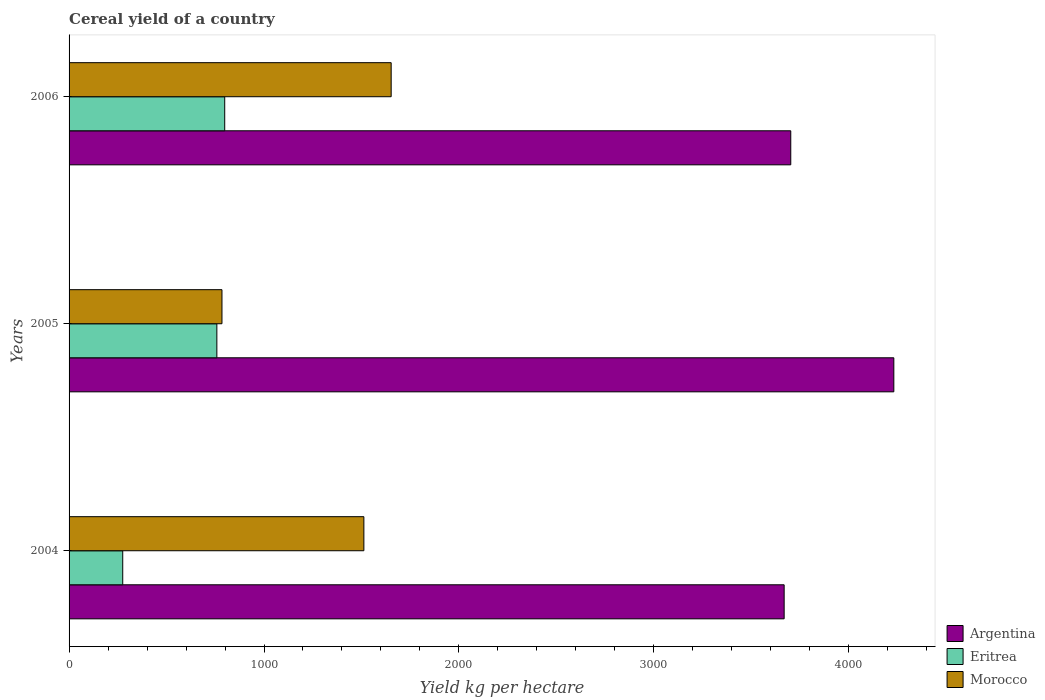How many different coloured bars are there?
Keep it short and to the point. 3. How many groups of bars are there?
Make the answer very short. 3. What is the label of the 3rd group of bars from the top?
Your answer should be very brief. 2004. In how many cases, is the number of bars for a given year not equal to the number of legend labels?
Your answer should be compact. 0. What is the total cereal yield in Eritrea in 2004?
Offer a very short reply. 275.29. Across all years, what is the maximum total cereal yield in Argentina?
Give a very brief answer. 4231.04. Across all years, what is the minimum total cereal yield in Eritrea?
Make the answer very short. 275.29. In which year was the total cereal yield in Morocco minimum?
Provide a short and direct response. 2005. What is the total total cereal yield in Argentina in the graph?
Offer a terse response. 1.16e+04. What is the difference between the total cereal yield in Eritrea in 2004 and that in 2006?
Provide a short and direct response. -523.19. What is the difference between the total cereal yield in Eritrea in 2004 and the total cereal yield in Morocco in 2005?
Offer a terse response. -509.06. What is the average total cereal yield in Morocco per year?
Provide a short and direct response. 1316.36. In the year 2006, what is the difference between the total cereal yield in Eritrea and total cereal yield in Morocco?
Provide a short and direct response. -853.93. In how many years, is the total cereal yield in Argentina greater than 4000 kg per hectare?
Your answer should be compact. 1. What is the ratio of the total cereal yield in Morocco in 2004 to that in 2006?
Provide a short and direct response. 0.92. Is the total cereal yield in Argentina in 2005 less than that in 2006?
Your response must be concise. No. Is the difference between the total cereal yield in Eritrea in 2004 and 2005 greater than the difference between the total cereal yield in Morocco in 2004 and 2005?
Provide a short and direct response. No. What is the difference between the highest and the second highest total cereal yield in Eritrea?
Your answer should be compact. 40.28. What is the difference between the highest and the lowest total cereal yield in Eritrea?
Make the answer very short. 523.19. In how many years, is the total cereal yield in Morocco greater than the average total cereal yield in Morocco taken over all years?
Offer a very short reply. 2. Is the sum of the total cereal yield in Eritrea in 2004 and 2006 greater than the maximum total cereal yield in Argentina across all years?
Your answer should be compact. No. What does the 1st bar from the top in 2004 represents?
Ensure brevity in your answer.  Morocco. What does the 3rd bar from the bottom in 2005 represents?
Your response must be concise. Morocco. Is it the case that in every year, the sum of the total cereal yield in Morocco and total cereal yield in Argentina is greater than the total cereal yield in Eritrea?
Provide a short and direct response. Yes. How many bars are there?
Offer a very short reply. 9. Are all the bars in the graph horizontal?
Provide a short and direct response. Yes. How many years are there in the graph?
Your response must be concise. 3. Where does the legend appear in the graph?
Your answer should be compact. Bottom right. How are the legend labels stacked?
Give a very brief answer. Vertical. What is the title of the graph?
Ensure brevity in your answer.  Cereal yield of a country. Does "Korea (Democratic)" appear as one of the legend labels in the graph?
Provide a succinct answer. No. What is the label or title of the X-axis?
Ensure brevity in your answer.  Yield kg per hectare. What is the label or title of the Y-axis?
Offer a very short reply. Years. What is the Yield kg per hectare of Argentina in 2004?
Your response must be concise. 3668.39. What is the Yield kg per hectare of Eritrea in 2004?
Make the answer very short. 275.29. What is the Yield kg per hectare in Morocco in 2004?
Your response must be concise. 1512.34. What is the Yield kg per hectare in Argentina in 2005?
Keep it short and to the point. 4231.04. What is the Yield kg per hectare of Eritrea in 2005?
Offer a terse response. 758.2. What is the Yield kg per hectare in Morocco in 2005?
Keep it short and to the point. 784.35. What is the Yield kg per hectare in Argentina in 2006?
Keep it short and to the point. 3702.29. What is the Yield kg per hectare of Eritrea in 2006?
Your response must be concise. 798.48. What is the Yield kg per hectare in Morocco in 2006?
Provide a succinct answer. 1652.41. Across all years, what is the maximum Yield kg per hectare in Argentina?
Your answer should be compact. 4231.04. Across all years, what is the maximum Yield kg per hectare of Eritrea?
Your answer should be very brief. 798.48. Across all years, what is the maximum Yield kg per hectare of Morocco?
Your answer should be compact. 1652.41. Across all years, what is the minimum Yield kg per hectare of Argentina?
Keep it short and to the point. 3668.39. Across all years, what is the minimum Yield kg per hectare of Eritrea?
Make the answer very short. 275.29. Across all years, what is the minimum Yield kg per hectare of Morocco?
Ensure brevity in your answer.  784.35. What is the total Yield kg per hectare in Argentina in the graph?
Make the answer very short. 1.16e+04. What is the total Yield kg per hectare of Eritrea in the graph?
Your response must be concise. 1831.96. What is the total Yield kg per hectare in Morocco in the graph?
Provide a succinct answer. 3949.09. What is the difference between the Yield kg per hectare of Argentina in 2004 and that in 2005?
Ensure brevity in your answer.  -562.65. What is the difference between the Yield kg per hectare of Eritrea in 2004 and that in 2005?
Offer a terse response. -482.91. What is the difference between the Yield kg per hectare in Morocco in 2004 and that in 2005?
Make the answer very short. 727.99. What is the difference between the Yield kg per hectare of Argentina in 2004 and that in 2006?
Provide a short and direct response. -33.9. What is the difference between the Yield kg per hectare in Eritrea in 2004 and that in 2006?
Your response must be concise. -523.19. What is the difference between the Yield kg per hectare in Morocco in 2004 and that in 2006?
Your response must be concise. -140.07. What is the difference between the Yield kg per hectare of Argentina in 2005 and that in 2006?
Provide a short and direct response. 528.75. What is the difference between the Yield kg per hectare in Eritrea in 2005 and that in 2006?
Your answer should be compact. -40.28. What is the difference between the Yield kg per hectare in Morocco in 2005 and that in 2006?
Give a very brief answer. -868.06. What is the difference between the Yield kg per hectare of Argentina in 2004 and the Yield kg per hectare of Eritrea in 2005?
Your answer should be compact. 2910.19. What is the difference between the Yield kg per hectare in Argentina in 2004 and the Yield kg per hectare in Morocco in 2005?
Provide a short and direct response. 2884.04. What is the difference between the Yield kg per hectare of Eritrea in 2004 and the Yield kg per hectare of Morocco in 2005?
Offer a very short reply. -509.06. What is the difference between the Yield kg per hectare in Argentina in 2004 and the Yield kg per hectare in Eritrea in 2006?
Keep it short and to the point. 2869.91. What is the difference between the Yield kg per hectare of Argentina in 2004 and the Yield kg per hectare of Morocco in 2006?
Your response must be concise. 2015.98. What is the difference between the Yield kg per hectare of Eritrea in 2004 and the Yield kg per hectare of Morocco in 2006?
Provide a succinct answer. -1377.12. What is the difference between the Yield kg per hectare of Argentina in 2005 and the Yield kg per hectare of Eritrea in 2006?
Ensure brevity in your answer.  3432.56. What is the difference between the Yield kg per hectare in Argentina in 2005 and the Yield kg per hectare in Morocco in 2006?
Provide a succinct answer. 2578.63. What is the difference between the Yield kg per hectare of Eritrea in 2005 and the Yield kg per hectare of Morocco in 2006?
Make the answer very short. -894.21. What is the average Yield kg per hectare in Argentina per year?
Make the answer very short. 3867.24. What is the average Yield kg per hectare in Eritrea per year?
Make the answer very short. 610.65. What is the average Yield kg per hectare in Morocco per year?
Provide a short and direct response. 1316.36. In the year 2004, what is the difference between the Yield kg per hectare of Argentina and Yield kg per hectare of Eritrea?
Provide a succinct answer. 3393.1. In the year 2004, what is the difference between the Yield kg per hectare in Argentina and Yield kg per hectare in Morocco?
Offer a very short reply. 2156.05. In the year 2004, what is the difference between the Yield kg per hectare in Eritrea and Yield kg per hectare in Morocco?
Provide a succinct answer. -1237.05. In the year 2005, what is the difference between the Yield kg per hectare of Argentina and Yield kg per hectare of Eritrea?
Your response must be concise. 3472.84. In the year 2005, what is the difference between the Yield kg per hectare of Argentina and Yield kg per hectare of Morocco?
Offer a terse response. 3446.69. In the year 2005, what is the difference between the Yield kg per hectare in Eritrea and Yield kg per hectare in Morocco?
Ensure brevity in your answer.  -26.15. In the year 2006, what is the difference between the Yield kg per hectare of Argentina and Yield kg per hectare of Eritrea?
Your answer should be very brief. 2903.81. In the year 2006, what is the difference between the Yield kg per hectare of Argentina and Yield kg per hectare of Morocco?
Your answer should be very brief. 2049.88. In the year 2006, what is the difference between the Yield kg per hectare of Eritrea and Yield kg per hectare of Morocco?
Your answer should be very brief. -853.93. What is the ratio of the Yield kg per hectare of Argentina in 2004 to that in 2005?
Provide a short and direct response. 0.87. What is the ratio of the Yield kg per hectare of Eritrea in 2004 to that in 2005?
Provide a short and direct response. 0.36. What is the ratio of the Yield kg per hectare of Morocco in 2004 to that in 2005?
Your answer should be very brief. 1.93. What is the ratio of the Yield kg per hectare of Argentina in 2004 to that in 2006?
Your answer should be compact. 0.99. What is the ratio of the Yield kg per hectare of Eritrea in 2004 to that in 2006?
Your response must be concise. 0.34. What is the ratio of the Yield kg per hectare of Morocco in 2004 to that in 2006?
Provide a succinct answer. 0.92. What is the ratio of the Yield kg per hectare of Argentina in 2005 to that in 2006?
Make the answer very short. 1.14. What is the ratio of the Yield kg per hectare of Eritrea in 2005 to that in 2006?
Provide a short and direct response. 0.95. What is the ratio of the Yield kg per hectare in Morocco in 2005 to that in 2006?
Your response must be concise. 0.47. What is the difference between the highest and the second highest Yield kg per hectare in Argentina?
Keep it short and to the point. 528.75. What is the difference between the highest and the second highest Yield kg per hectare in Eritrea?
Ensure brevity in your answer.  40.28. What is the difference between the highest and the second highest Yield kg per hectare of Morocco?
Provide a short and direct response. 140.07. What is the difference between the highest and the lowest Yield kg per hectare of Argentina?
Your answer should be compact. 562.65. What is the difference between the highest and the lowest Yield kg per hectare in Eritrea?
Ensure brevity in your answer.  523.19. What is the difference between the highest and the lowest Yield kg per hectare of Morocco?
Keep it short and to the point. 868.06. 